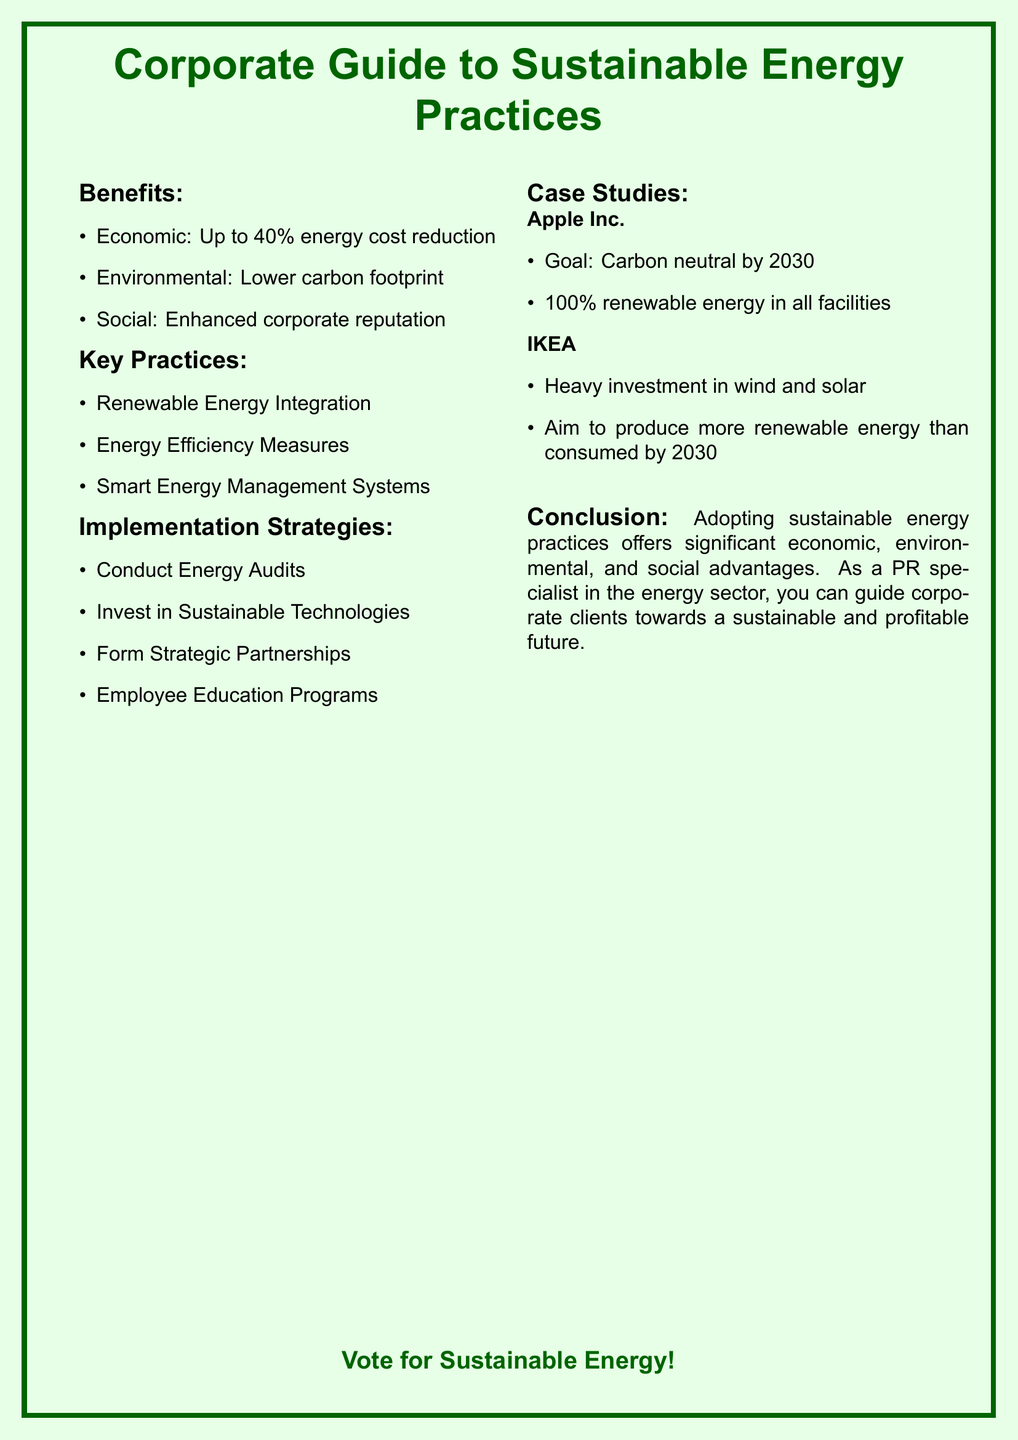What is the main title of the pamphlet? The title is prominently displayed at the top of the document, emphasizing corporate engagement with sustainable energy.
Answer: Corporate Guide to Sustainable Energy Practices What is the potential economic benefit mentioned? This information highlights the extent of cost savings that corporate clients can expect from implementing sustainable practices.
Answer: Up to 40% energy cost reduction Which company aims for carbon neutrality by 2030? This company is noted for its ambitious environmental goal, showcasing a significant commitment to sustainability.
Answer: Apple Inc What does IKEA aim to produce more of than consumed by 2030? This reflects IKEA's initiative towards renewable energy production in relation to its consumption.
Answer: Renewable energy What implementation strategy involves educating employees? This strategy focuses on enhancing staff knowledge and awareness regarding sustainable practices.
Answer: Employee Education Programs What is one key practice for energy sustainability listed? This question highlights one of the essential actions companies should take to improve energy efficiency.
Answer: Renewable Energy Integration What social benefit is noted in the document? This benefit emphasizes the positive impact on public perception of a corporation engaged in sustainable practices.
Answer: Enhanced corporate reputation Which strategy includes forming partnerships? This strategy is aimed at leveraging collaboration to promote sustainable practices effectively.
Answer: Form Strategic Partnerships What type of energy systems are mentioned in the key practices? This refers to a modern technological approach to managing energy consumption within corporate settings.
Answer: Smart Energy Management Systems 